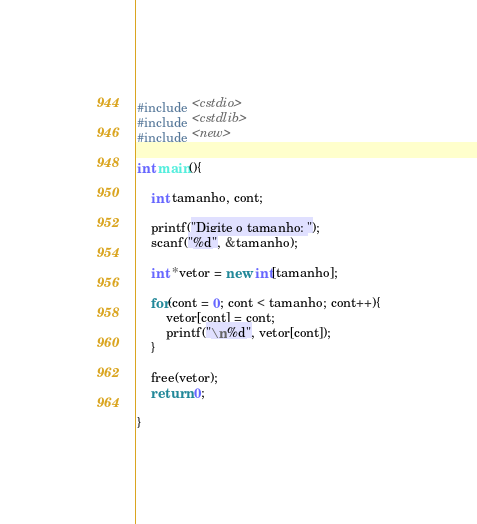<code> <loc_0><loc_0><loc_500><loc_500><_C++_>#include <cstdio>
#include <cstdlib>
#include <new>

int main(){

    int tamanho, cont;

    printf("Digite o tamanho: ");
    scanf("%d", &tamanho);

    int *vetor = new int[tamanho];

    for(cont = 0; cont < tamanho; cont++){
        vetor[cont] = cont;
        printf("\n%d", vetor[cont]);
    }

    free(vetor);
    return 0;

}</code> 